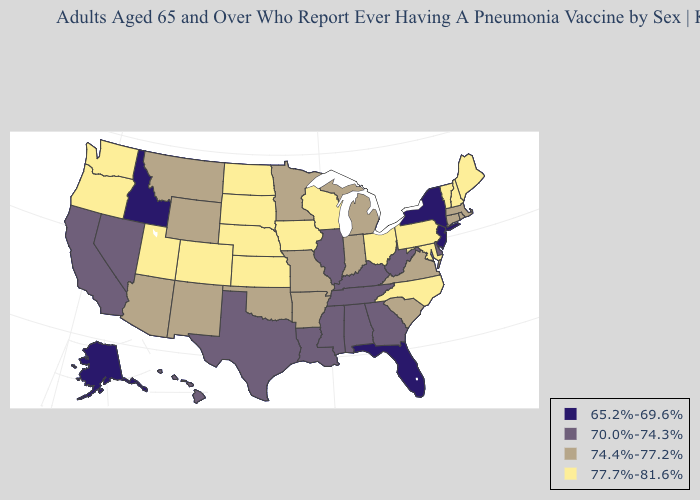Name the states that have a value in the range 70.0%-74.3%?
Quick response, please. Alabama, California, Delaware, Georgia, Hawaii, Illinois, Kentucky, Louisiana, Mississippi, Nevada, Tennessee, Texas, West Virginia. Name the states that have a value in the range 74.4%-77.2%?
Concise answer only. Arizona, Arkansas, Connecticut, Indiana, Massachusetts, Michigan, Minnesota, Missouri, Montana, New Mexico, Oklahoma, Rhode Island, South Carolina, Virginia, Wyoming. Name the states that have a value in the range 74.4%-77.2%?
Concise answer only. Arizona, Arkansas, Connecticut, Indiana, Massachusetts, Michigan, Minnesota, Missouri, Montana, New Mexico, Oklahoma, Rhode Island, South Carolina, Virginia, Wyoming. What is the lowest value in states that border Virginia?
Short answer required. 70.0%-74.3%. Does Wyoming have the lowest value in the USA?
Concise answer only. No. Name the states that have a value in the range 70.0%-74.3%?
Short answer required. Alabama, California, Delaware, Georgia, Hawaii, Illinois, Kentucky, Louisiana, Mississippi, Nevada, Tennessee, Texas, West Virginia. What is the lowest value in the MidWest?
Give a very brief answer. 70.0%-74.3%. Name the states that have a value in the range 74.4%-77.2%?
Concise answer only. Arizona, Arkansas, Connecticut, Indiana, Massachusetts, Michigan, Minnesota, Missouri, Montana, New Mexico, Oklahoma, Rhode Island, South Carolina, Virginia, Wyoming. Does West Virginia have a lower value than Hawaii?
Quick response, please. No. Name the states that have a value in the range 77.7%-81.6%?
Quick response, please. Colorado, Iowa, Kansas, Maine, Maryland, Nebraska, New Hampshire, North Carolina, North Dakota, Ohio, Oregon, Pennsylvania, South Dakota, Utah, Vermont, Washington, Wisconsin. Among the states that border Arizona , does Colorado have the lowest value?
Keep it brief. No. Does the first symbol in the legend represent the smallest category?
Short answer required. Yes. Name the states that have a value in the range 65.2%-69.6%?
Give a very brief answer. Alaska, Florida, Idaho, New Jersey, New York. What is the highest value in the USA?
Concise answer only. 77.7%-81.6%. 